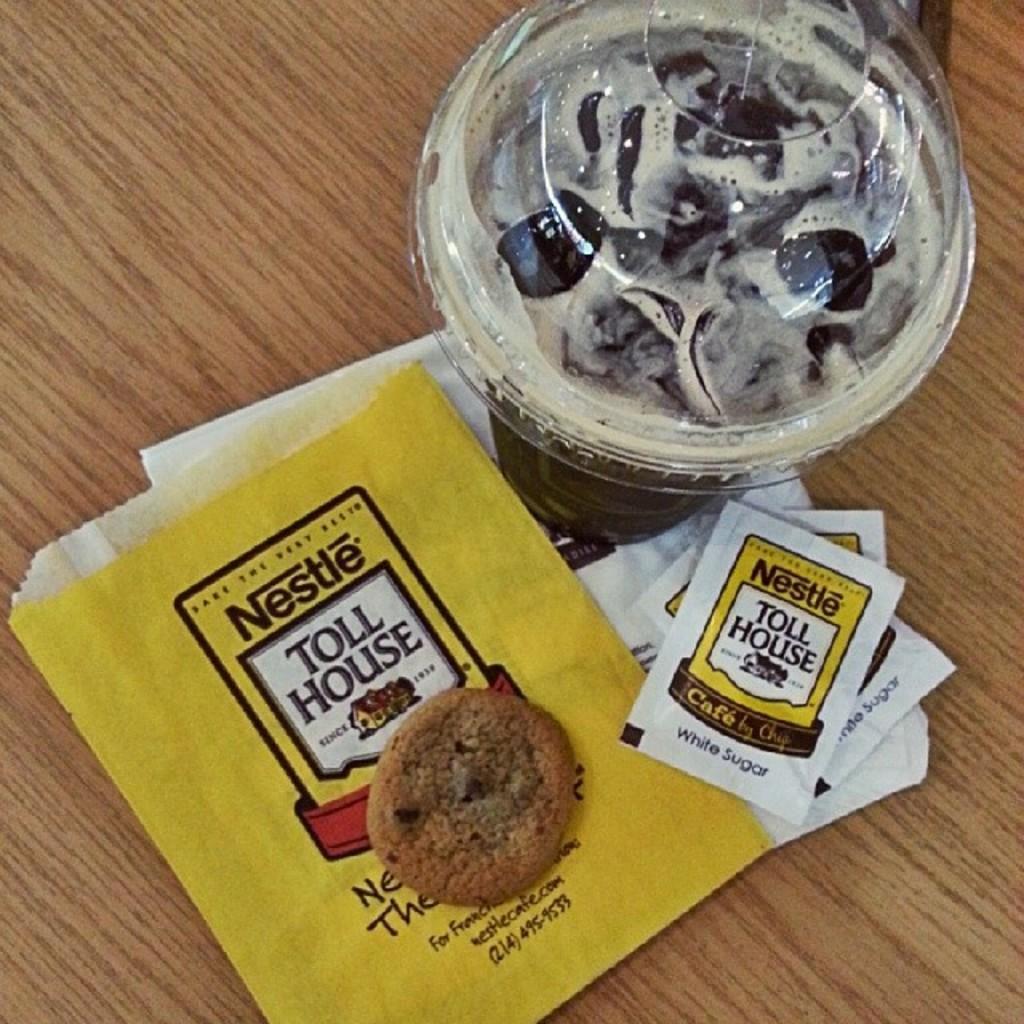Please provide a concise description of this image. In this image there is a table with coffee cup, sugar packets and cookie on the cover. 